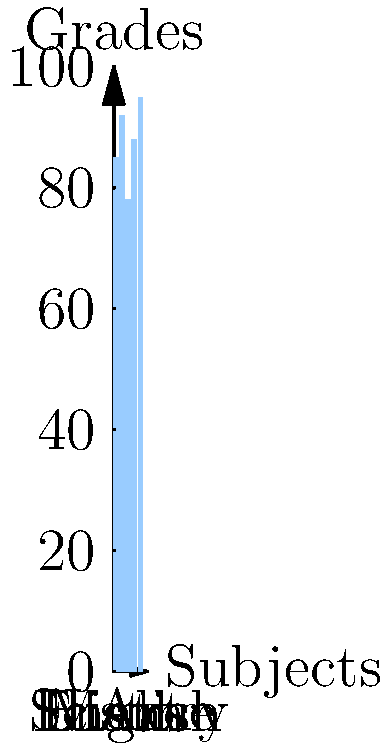Looking at John's grades across different subjects, which subject shows the greatest difference compared to his grade in English? To find the subject with the greatest difference from John's English grade, we need to:

1. Identify John's English grade: 78

2. Calculate the difference between each subject's grade and the English grade:
   Math: |85 - 78| = 7
   Science: |92 - 78| = 14
   History: |88 - 78| = 10
   Art: |95 - 78| = 17

3. Compare the differences to find the largest:
   The largest difference is 17, corresponding to Art.

Therefore, Art shows the greatest difference compared to John's English grade.
Answer: Art 